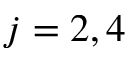<formula> <loc_0><loc_0><loc_500><loc_500>j = 2 , 4</formula> 